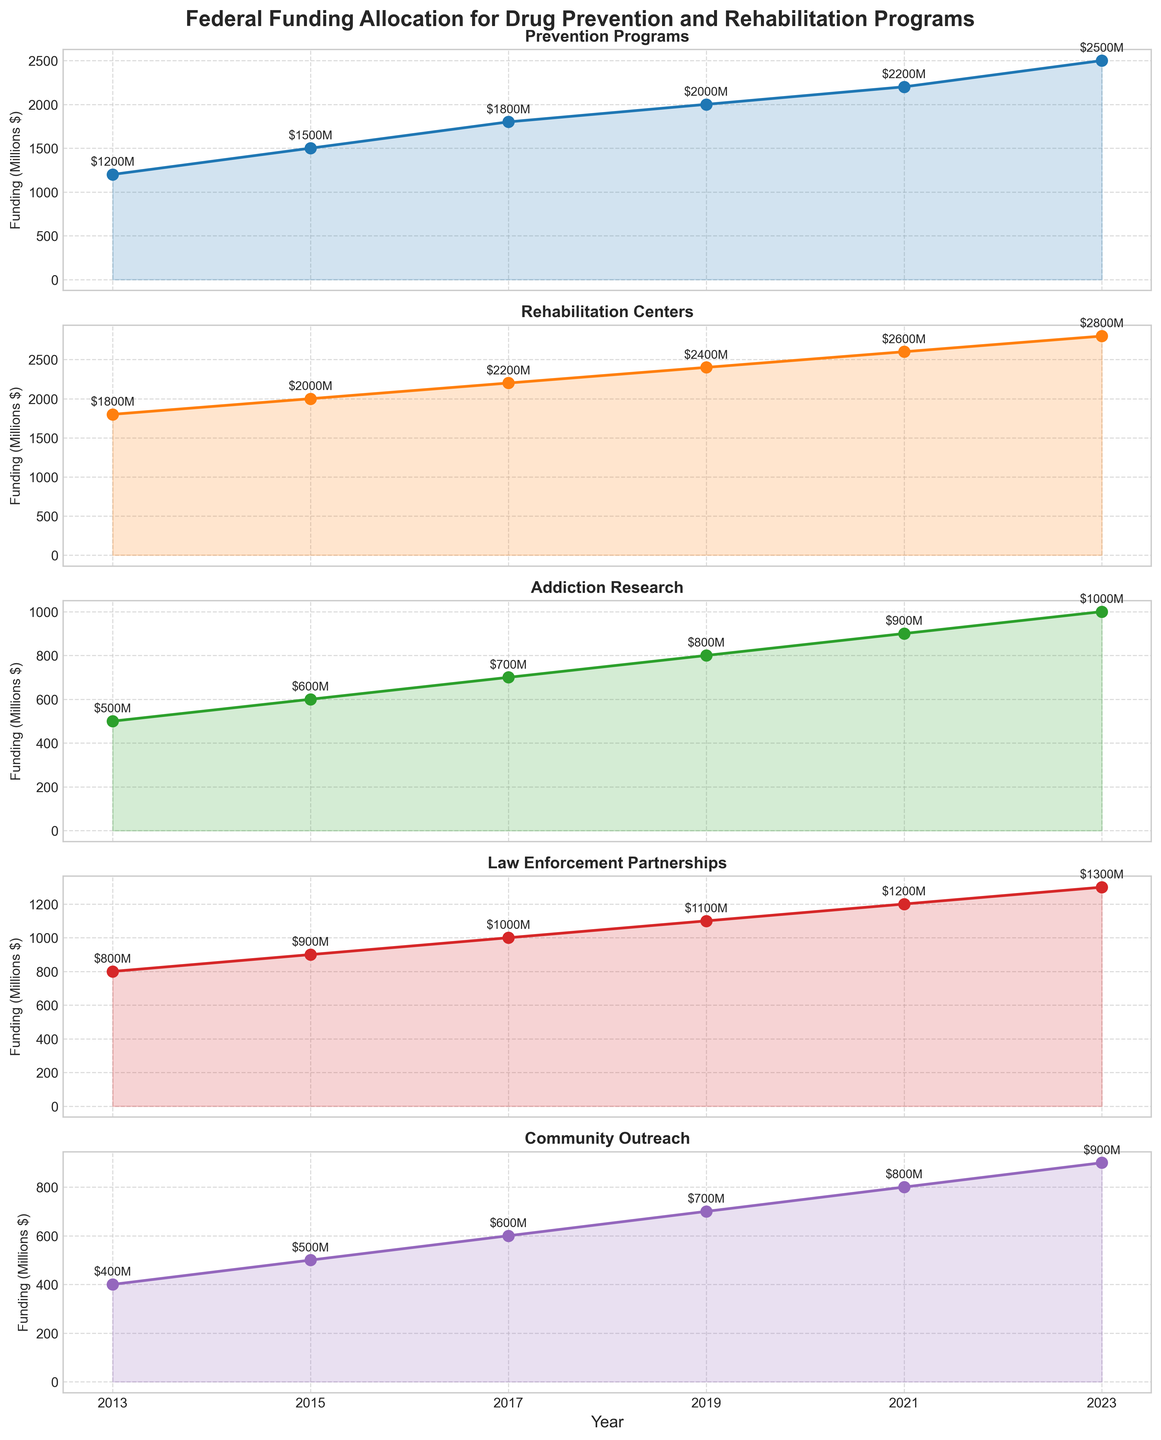What is the title of the figure? The title is usually located at the top center of the figure. It provides an overview of what the figure is about. In this case, it mentions the federal funding allocation.
Answer: Federal Funding Allocation for Drug Prevention and Rehabilitation Programs How many years does the figure cover? The x-axis lists the years for which data is available. By counting these unique years, we determine the total duration.
Answer: Six years Which funding category received the highest allocation in 2023? Each subplot represents a different funding category. By observing the value for 2023 in each subplot, we can compare the amounts.
Answer: Rehabilitation Centers Which category saw the largest increase in funding from 2013 to 2023? To find the largest increase, calculate the difference between the 2023 and 2013 values for each category and compare.
Answer: Prevention Programs What is the funding trend for Law Enforcement Partnerships from 2013 to 2023? By observing the line plot for Law Enforcement Partnerships, note the changes and direction of the line over the years.
Answer: Increasing How does the funding for Community Outreach in 2015 compare to that in 2023? Compare the values of Community Outreach in 2015 and 2023 by looking at the respective points on the subplot.
Answer: 400 (2015) and 900 (2023) What is the average funding for Addiction Research over the last decade? Sum the funding amounts for all available years for Addiction Research and divide by the number of years (6).
Answer: 750 Which category has the most consistent funding increase over the years? Evaluate each subplot's trendline to see which category shows a steady increase without major jumps or drops.
Answer: Community Outreach What was the total funding across all categories in 2019? Sum the funding values in 2019 for all categories.
Answer: 7000 Between which two consecutive years did Rehabilitation Centers see the largest increase in funding? Calculate the difference in funding for each consecutive year for Rehabilitation Centers and identify the largest increase.
Answer: 2021 to 2023 